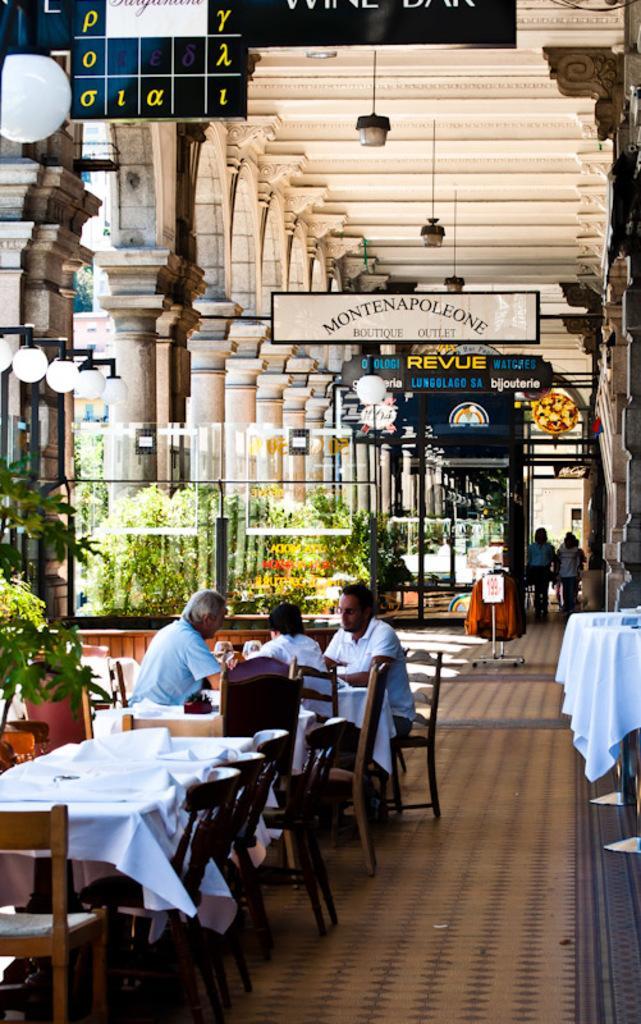How would you summarize this image in a sentence or two? In this image, there are a few people. We can see some tables covered with a cloth and some objects are placed on them. We can see some chairs and the ground with some objects. We can see some pillars, boards with text. We can see some plants, lights. We can also see the roof with some objects attached to it. We can also see some objects on the right. 